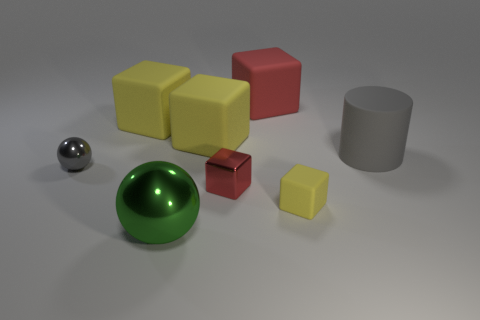How many large green spheres are left of the red rubber block?
Your answer should be compact. 1. Do the yellow object in front of the small gray metallic thing and the big red rubber thing have the same shape?
Ensure brevity in your answer.  Yes. Are there any other small metal things of the same shape as the green thing?
Offer a terse response. Yes. There is a small thing that is the same color as the cylinder; what is its material?
Offer a terse response. Metal. The yellow object in front of the red thing that is in front of the big gray cylinder is what shape?
Ensure brevity in your answer.  Cube. What number of objects are made of the same material as the big green ball?
Give a very brief answer. 2. What is the color of the cylinder that is the same material as the big red cube?
Keep it short and to the point. Gray. There is a yellow matte thing in front of the big object right of the block to the right of the big red rubber thing; what size is it?
Make the answer very short. Small. Is the number of small gray things less than the number of large yellow objects?
Your response must be concise. Yes. There is a tiny metallic thing that is the same shape as the tiny yellow matte thing; what is its color?
Offer a very short reply. Red. 